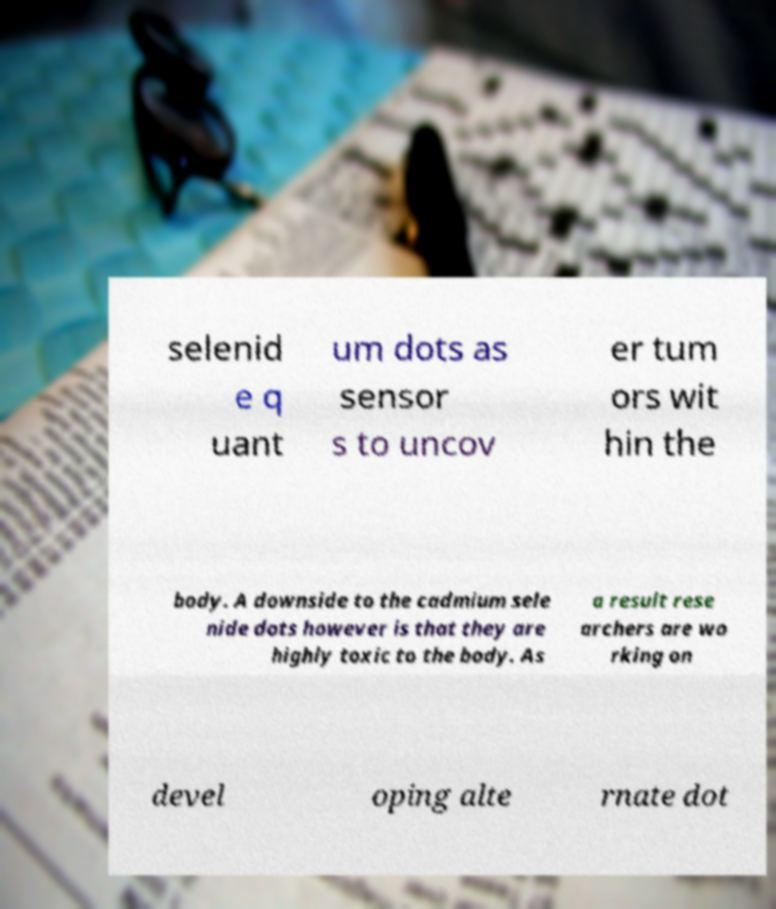There's text embedded in this image that I need extracted. Can you transcribe it verbatim? selenid e q uant um dots as sensor s to uncov er tum ors wit hin the body. A downside to the cadmium sele nide dots however is that they are highly toxic to the body. As a result rese archers are wo rking on devel oping alte rnate dot 